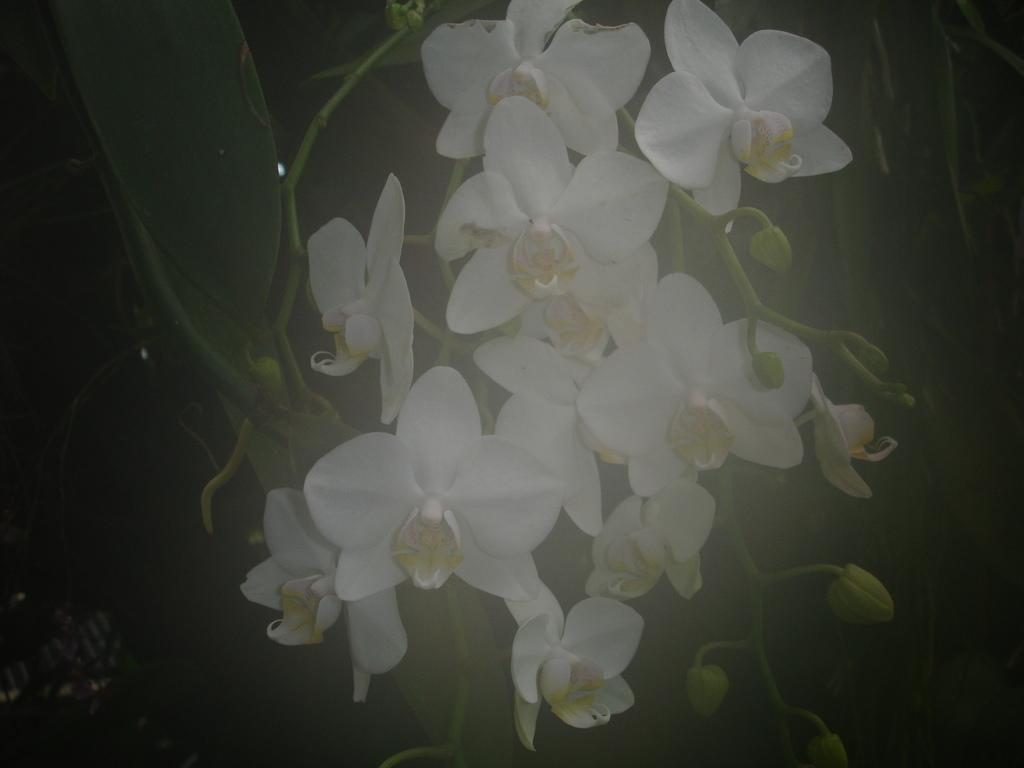How would you summarize this image in a sentence or two? In this picture, we see plants. These plants have flowers and these flowers are in white color. In the background, it is black in color. 